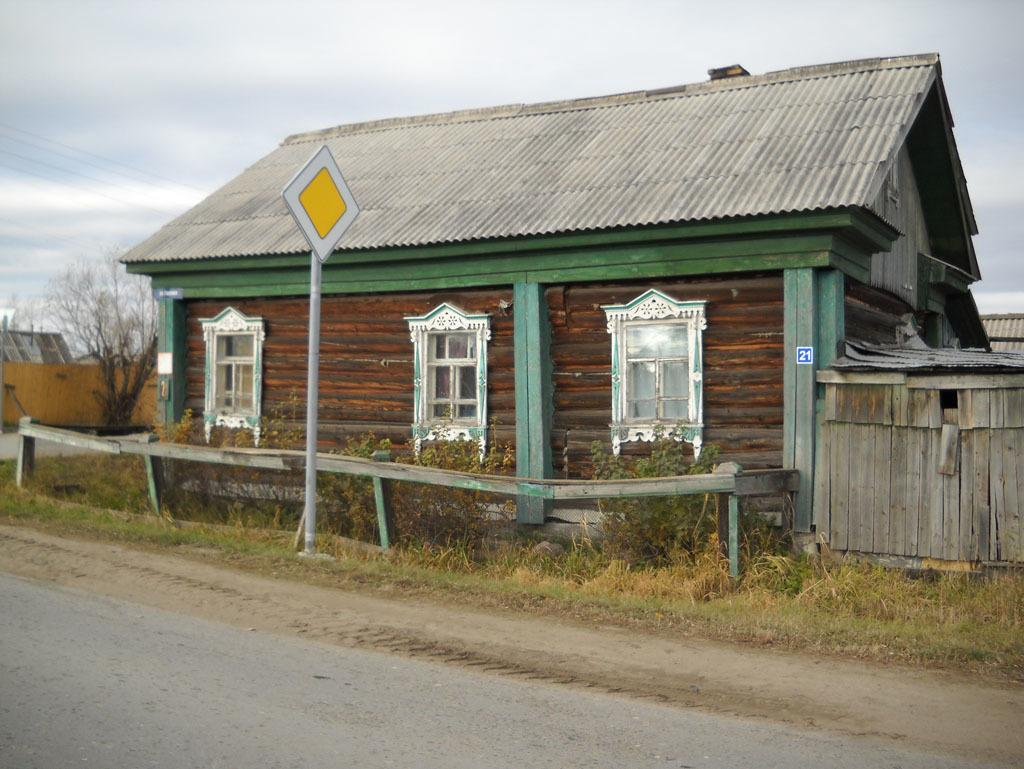What type of house is in the image? There is a wooden house in the image. What features can be seen on the house? The house has windows. What type of vegetation is present in the image? There is grass and a tree in the image. What other objects can be seen in the image? There is a plant, a pole, electric wires, and a road in the image. What is the condition of the sky in the image? The sky is cloudy in the image. What type of frame is used to hold the pen in the image? There is no pen or frame present in the image. What type of land can be seen in the image? The image does not specifically show land; it shows a wooden house, grass, a tree, a plant, a pole, electric wires, and a road. 